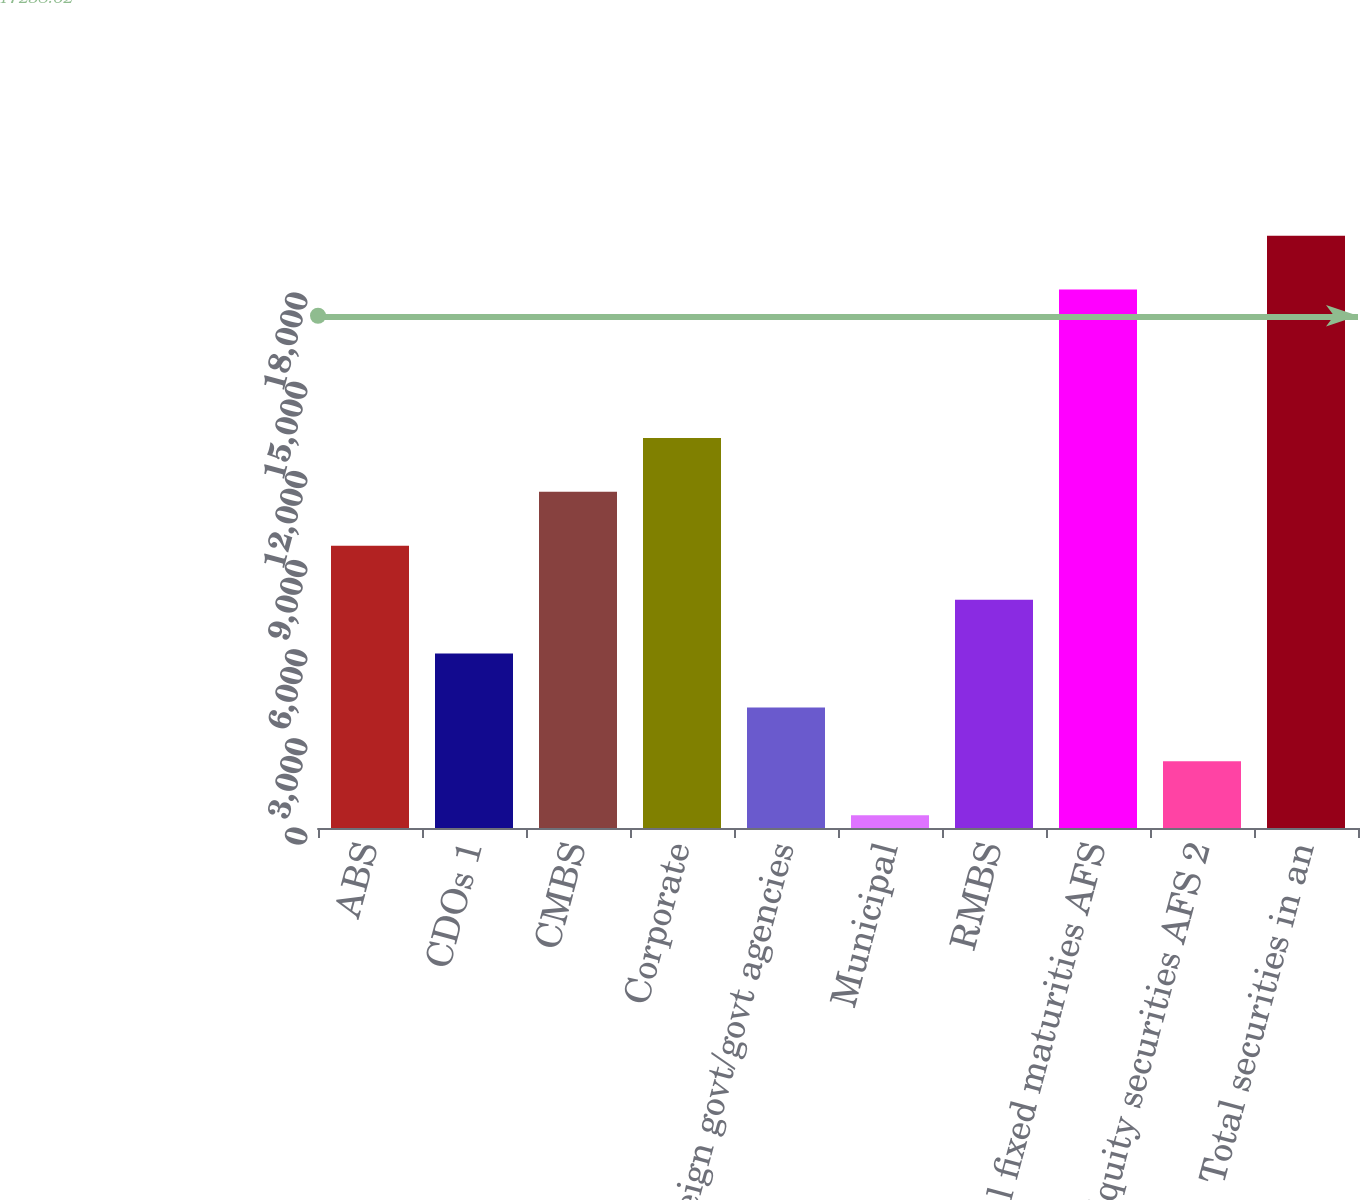Convert chart. <chart><loc_0><loc_0><loc_500><loc_500><bar_chart><fcel>ABS<fcel>CDOs 1<fcel>CMBS<fcel>Corporate<fcel>Foreign govt/govt agencies<fcel>Municipal<fcel>RMBS<fcel>Total fixed maturities AFS<fcel>Equity securities AFS 2<fcel>Total securities in an<nl><fcel>9499.5<fcel>5871.7<fcel>11313.4<fcel>13127.3<fcel>4057.8<fcel>430<fcel>7685.6<fcel>18120<fcel>2243.9<fcel>19933.9<nl></chart> 